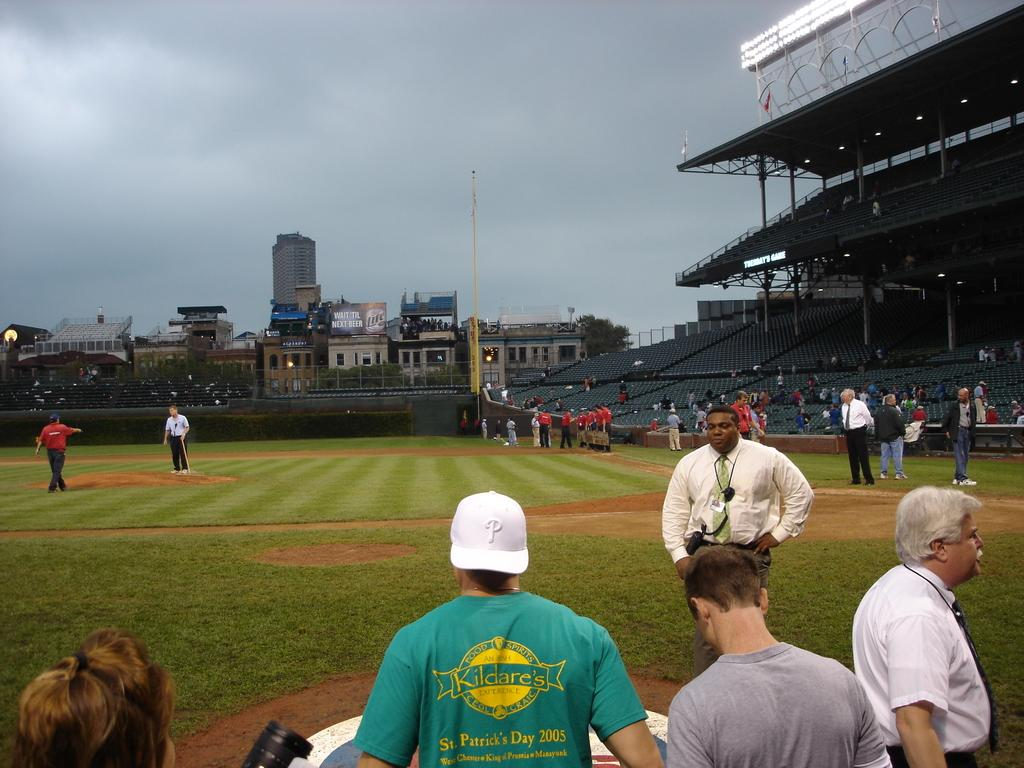<image>
Present a compact description of the photo's key features. a baseball field with spectators around the perimeter including one in a green KILDARE's t-shirt 